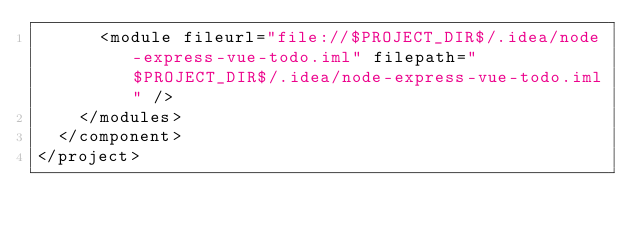Convert code to text. <code><loc_0><loc_0><loc_500><loc_500><_XML_>      <module fileurl="file://$PROJECT_DIR$/.idea/node-express-vue-todo.iml" filepath="$PROJECT_DIR$/.idea/node-express-vue-todo.iml" />
    </modules>
  </component>
</project></code> 